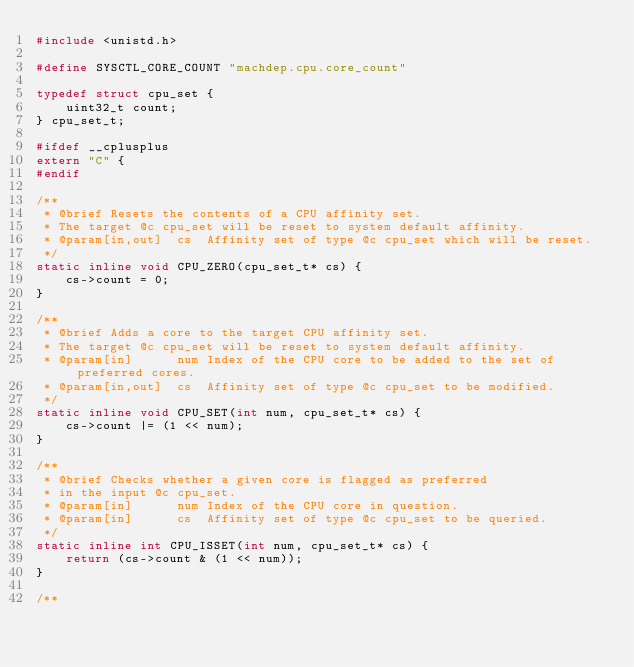Convert code to text. <code><loc_0><loc_0><loc_500><loc_500><_C++_>#include <unistd.h>

#define SYSCTL_CORE_COUNT "machdep.cpu.core_count"

typedef struct cpu_set {
    uint32_t count;
} cpu_set_t;

#ifdef __cplusplus
extern "C" {
#endif

/**
 * @brief Resets the contents of a CPU affinity set.
 * The target @c cpu_set will be reset to system default affinity.
 * @param[in,out]  cs  Affinity set of type @c cpu_set which will be reset.
 */
static inline void CPU_ZERO(cpu_set_t* cs) {
    cs->count = 0;
}

/**
 * @brief Adds a core to the target CPU affinity set.
 * The target @c cpu_set will be reset to system default affinity.
 * @param[in]      num Index of the CPU core to be added to the set of preferred cores.
 * @param[in,out]  cs  Affinity set of type @c cpu_set to be modified.
 */
static inline void CPU_SET(int num, cpu_set_t* cs) {
    cs->count |= (1 << num);
}

/**
 * @brief Checks whether a given core is flagged as preferred
 * in the input @c cpu_set.
 * @param[in]      num Index of the CPU core in question.
 * @param[in]      cs  Affinity set of type @c cpu_set to be queried.
 */
static inline int CPU_ISSET(int num, cpu_set_t* cs) {
    return (cs->count & (1 << num));
}

/**</code> 